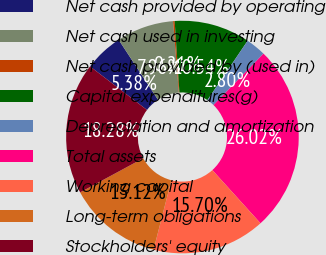Convert chart. <chart><loc_0><loc_0><loc_500><loc_500><pie_chart><fcel>Net cash provided by operating<fcel>Net cash used in investing<fcel>Net cash provided by (used in)<fcel>Capital expenditures(g)<fcel>Depreciation and amortization<fcel>Total assets<fcel>Working capital<fcel>Long-term obligations<fcel>Stockholders' equity<nl><fcel>5.38%<fcel>7.96%<fcel>0.21%<fcel>10.54%<fcel>2.8%<fcel>26.02%<fcel>15.7%<fcel>13.12%<fcel>18.28%<nl></chart> 